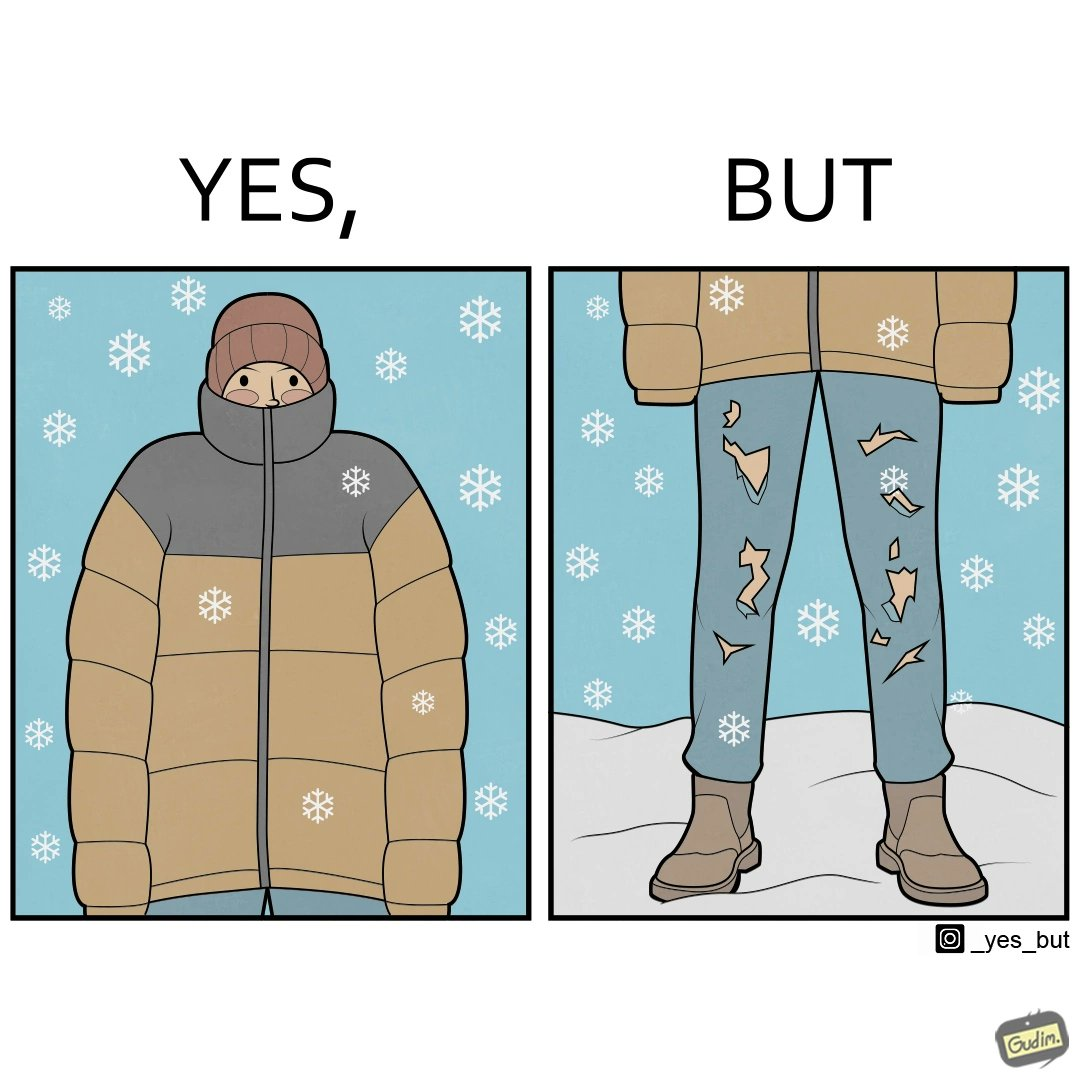Describe what you see in the left and right parts of this image. In the left part of the image: A person wearing a yellow jacket, with snow falling around him. They look like they are feeling cold as their jacket is covering half their face. In the right part of the image: A person wearing torn up trousers, standing in an area with snowfall. They are also wearing boots and a jacket. 